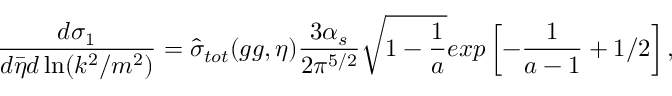<formula> <loc_0><loc_0><loc_500><loc_500>{ \frac { d \sigma _ { 1 } } { d \bar { \eta } d \ln ( k ^ { 2 } / m ^ { 2 } ) } } = \hat { \sigma } _ { t o t } ( g g , \eta ) \frac { 3 \alpha _ { s } } { 2 \pi ^ { 5 / 2 } } \sqrt { 1 - { \frac { 1 } { a } } } e x p \left [ - { \frac { 1 } { a - 1 } } + 1 / 2 \right ] ,</formula> 